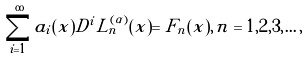Convert formula to latex. <formula><loc_0><loc_0><loc_500><loc_500>\sum _ { i = 1 } ^ { \infty } a _ { i } ( x ) D ^ { i } L _ { n } ^ { ( \alpha ) } ( x ) = F _ { n } ( x ) , \, n = 1 , 2 , 3 , \dots ,</formula> 